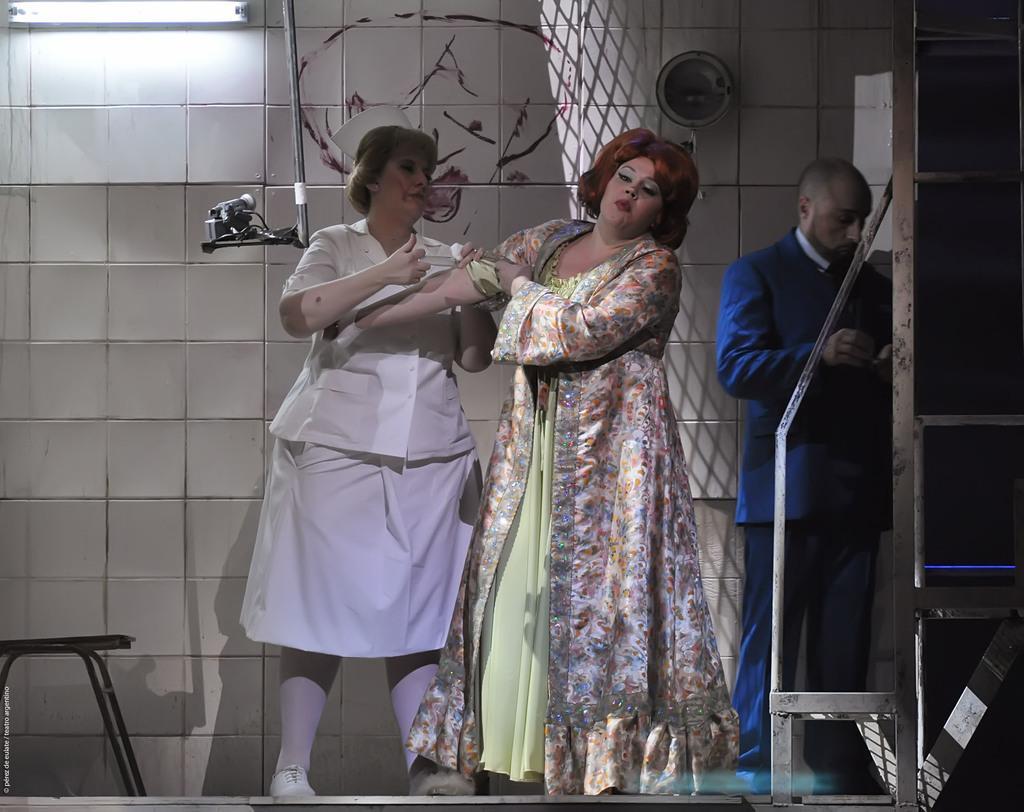Could you give a brief overview of what you see in this image? In this image there is a nurse giving the injection to the woman. Behind them there is a person standing. There is some metal object. On the left side of the image there is a stool. On the right side of the image there is a metal rack. In the background of the image there is a tube light and some object on the wall. There is some text at the bottom left of the image. 